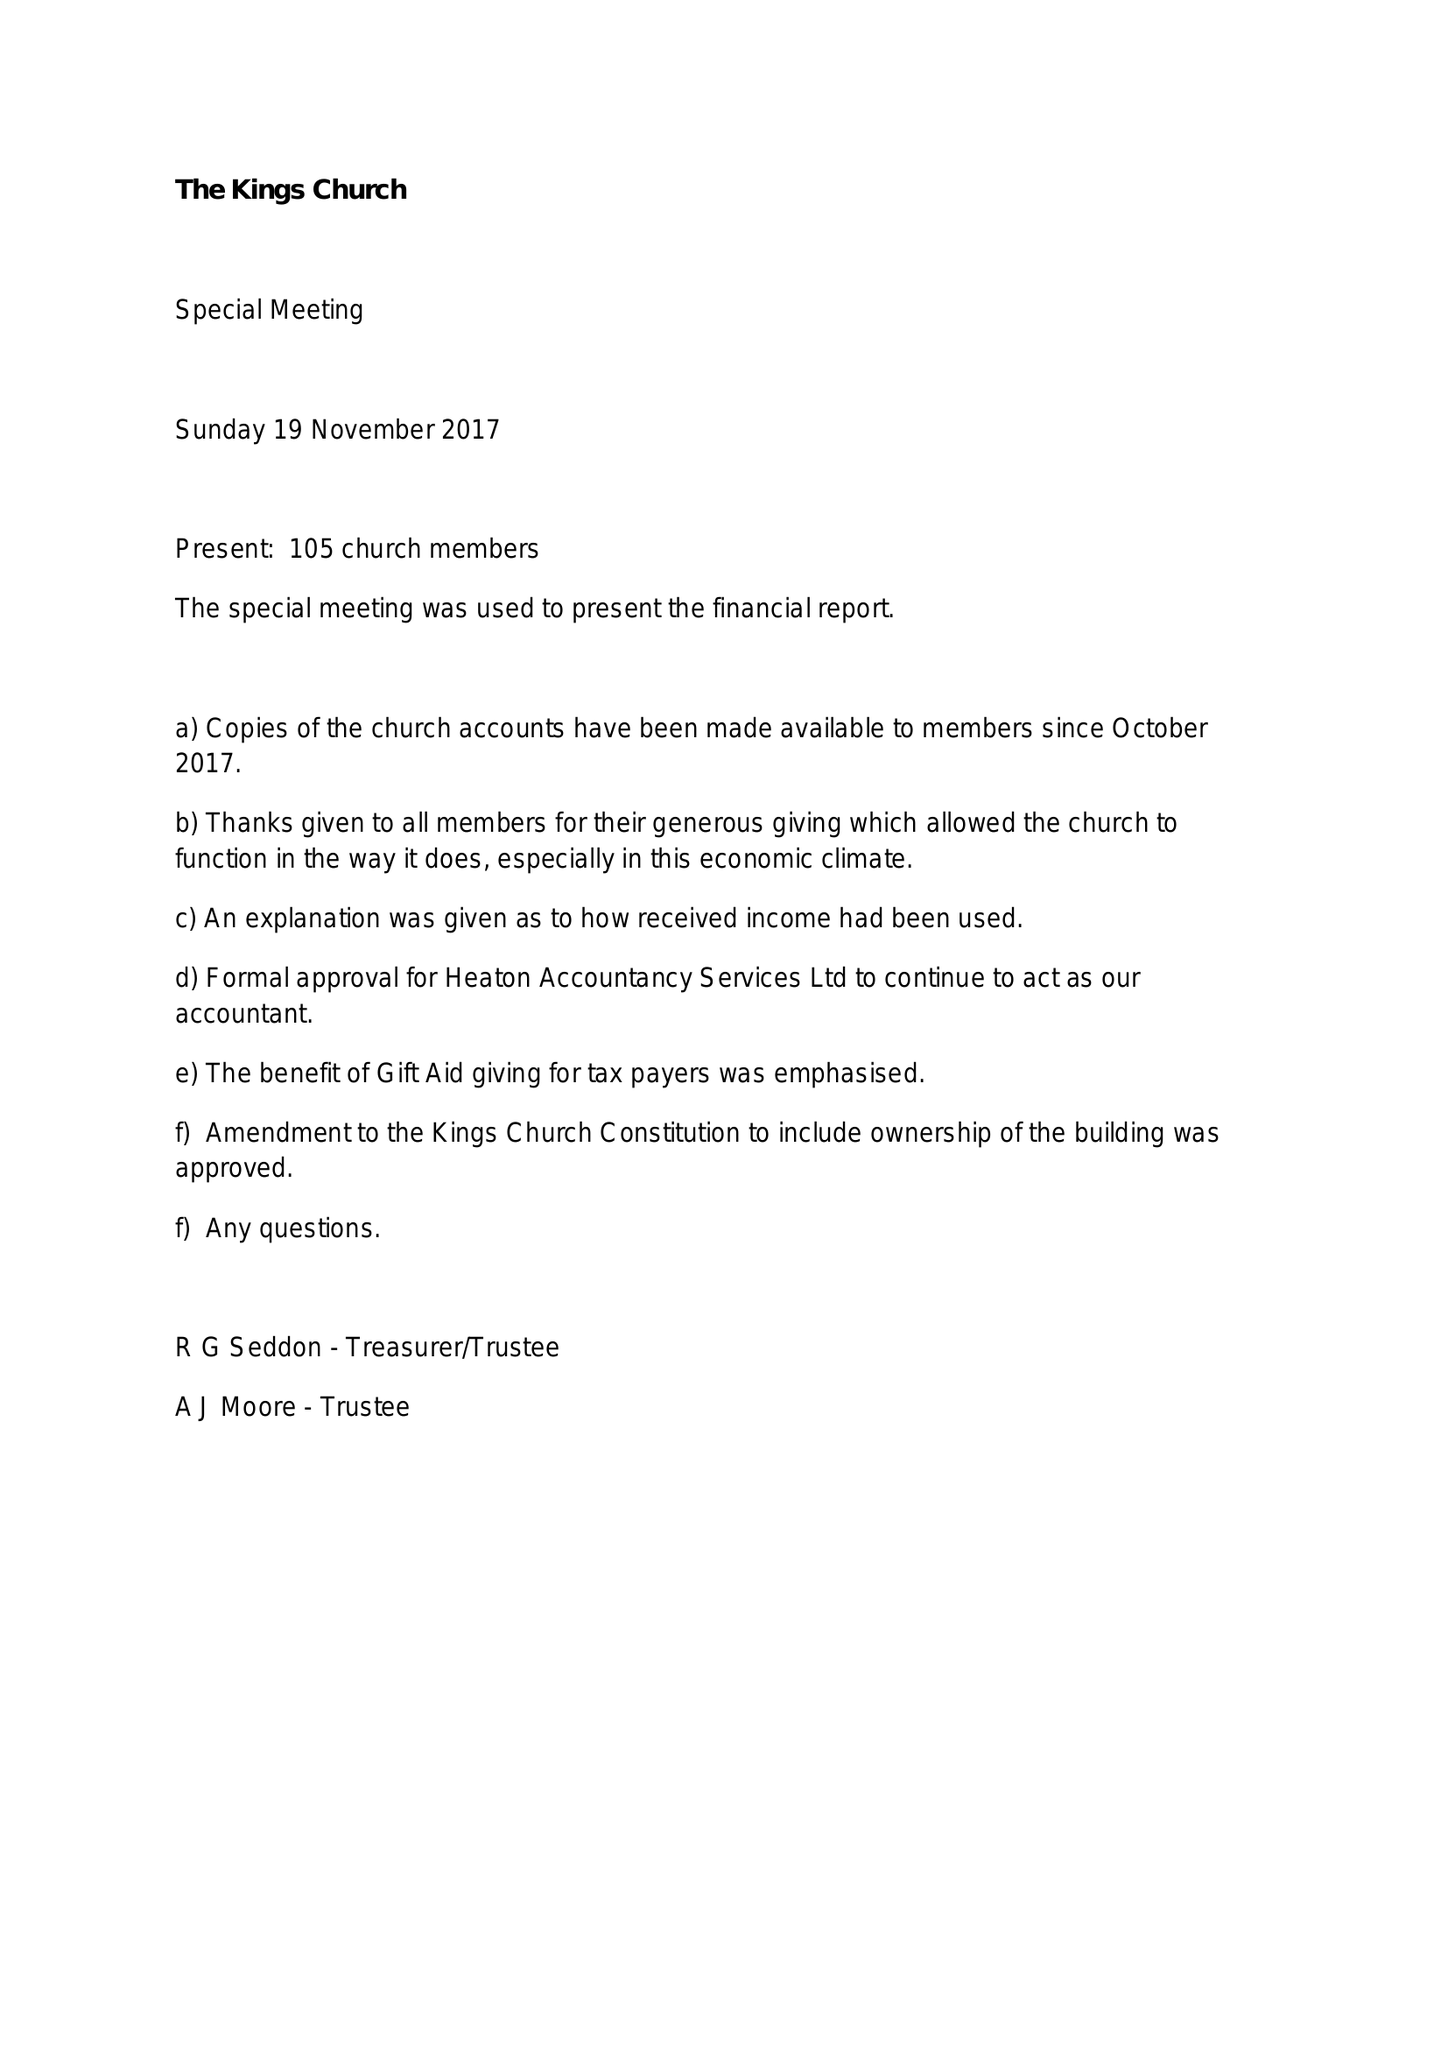What is the value for the address__postcode?
Answer the question using a single word or phrase. BL3 1HN 